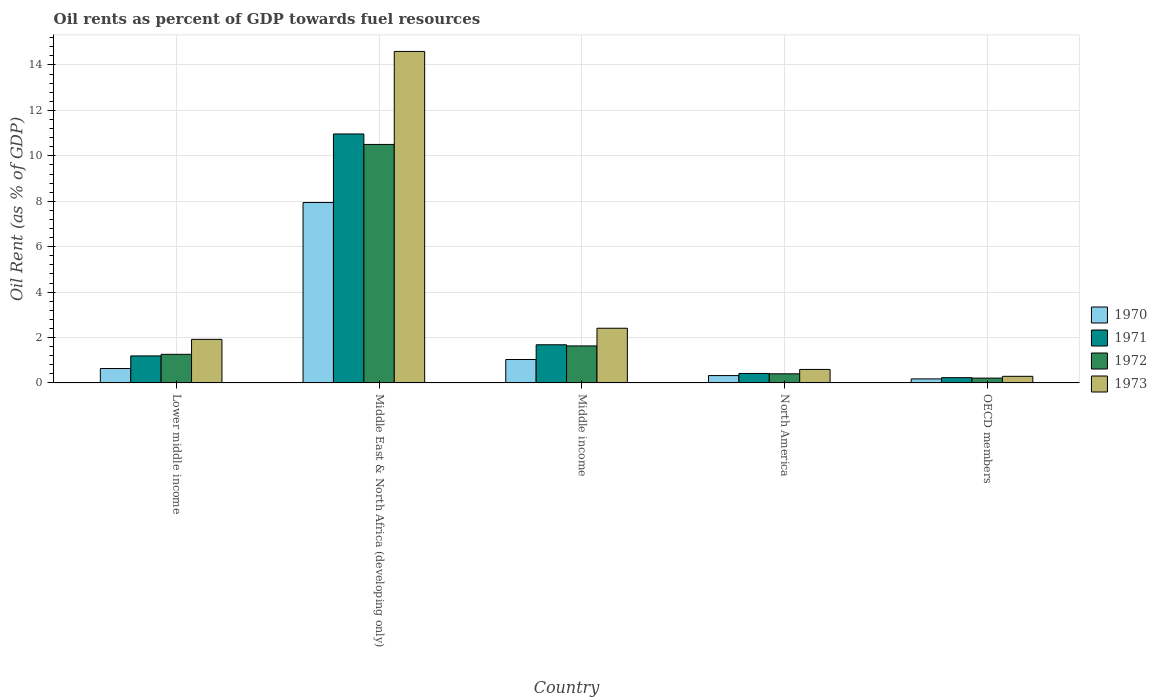How many different coloured bars are there?
Ensure brevity in your answer.  4. How many groups of bars are there?
Make the answer very short. 5. Are the number of bars on each tick of the X-axis equal?
Provide a succinct answer. Yes. How many bars are there on the 3rd tick from the right?
Your answer should be compact. 4. What is the label of the 4th group of bars from the left?
Provide a succinct answer. North America. What is the oil rent in 1972 in Lower middle income?
Provide a succinct answer. 1.26. Across all countries, what is the maximum oil rent in 1970?
Your response must be concise. 7.94. Across all countries, what is the minimum oil rent in 1973?
Give a very brief answer. 0.29. In which country was the oil rent in 1973 maximum?
Keep it short and to the point. Middle East & North Africa (developing only). In which country was the oil rent in 1971 minimum?
Provide a short and direct response. OECD members. What is the total oil rent in 1971 in the graph?
Ensure brevity in your answer.  14.48. What is the difference between the oil rent in 1972 in Middle East & North Africa (developing only) and that in Middle income?
Provide a short and direct response. 8.87. What is the difference between the oil rent in 1973 in Middle income and the oil rent in 1972 in Lower middle income?
Provide a succinct answer. 1.15. What is the average oil rent in 1971 per country?
Ensure brevity in your answer.  2.9. What is the difference between the oil rent of/in 1971 and oil rent of/in 1973 in Lower middle income?
Keep it short and to the point. -0.73. In how many countries, is the oil rent in 1971 greater than 3.6 %?
Provide a succinct answer. 1. What is the ratio of the oil rent in 1971 in Lower middle income to that in OECD members?
Make the answer very short. 5.12. Is the difference between the oil rent in 1971 in Middle income and North America greater than the difference between the oil rent in 1973 in Middle income and North America?
Ensure brevity in your answer.  No. What is the difference between the highest and the second highest oil rent in 1972?
Provide a short and direct response. -8.87. What is the difference between the highest and the lowest oil rent in 1970?
Make the answer very short. 7.77. Is it the case that in every country, the sum of the oil rent in 1973 and oil rent in 1972 is greater than the sum of oil rent in 1970 and oil rent in 1971?
Offer a terse response. No. What does the 2nd bar from the left in North America represents?
Provide a short and direct response. 1971. What does the 3rd bar from the right in North America represents?
Your response must be concise. 1971. Are all the bars in the graph horizontal?
Keep it short and to the point. No. What is the difference between two consecutive major ticks on the Y-axis?
Provide a succinct answer. 2. Does the graph contain any zero values?
Offer a very short reply. No. Does the graph contain grids?
Offer a very short reply. Yes. Where does the legend appear in the graph?
Keep it short and to the point. Center right. What is the title of the graph?
Provide a succinct answer. Oil rents as percent of GDP towards fuel resources. What is the label or title of the Y-axis?
Provide a short and direct response. Oil Rent (as % of GDP). What is the Oil Rent (as % of GDP) of 1970 in Lower middle income?
Keep it short and to the point. 0.63. What is the Oil Rent (as % of GDP) in 1971 in Lower middle income?
Give a very brief answer. 1.19. What is the Oil Rent (as % of GDP) in 1972 in Lower middle income?
Your response must be concise. 1.26. What is the Oil Rent (as % of GDP) in 1973 in Lower middle income?
Provide a short and direct response. 1.92. What is the Oil Rent (as % of GDP) in 1970 in Middle East & North Africa (developing only)?
Offer a very short reply. 7.94. What is the Oil Rent (as % of GDP) in 1971 in Middle East & North Africa (developing only)?
Your answer should be very brief. 10.96. What is the Oil Rent (as % of GDP) in 1972 in Middle East & North Africa (developing only)?
Your response must be concise. 10.5. What is the Oil Rent (as % of GDP) of 1973 in Middle East & North Africa (developing only)?
Provide a short and direct response. 14.6. What is the Oil Rent (as % of GDP) in 1970 in Middle income?
Make the answer very short. 1.03. What is the Oil Rent (as % of GDP) of 1971 in Middle income?
Your response must be concise. 1.68. What is the Oil Rent (as % of GDP) in 1972 in Middle income?
Offer a terse response. 1.63. What is the Oil Rent (as % of GDP) of 1973 in Middle income?
Your answer should be very brief. 2.41. What is the Oil Rent (as % of GDP) of 1970 in North America?
Make the answer very short. 0.32. What is the Oil Rent (as % of GDP) of 1971 in North America?
Offer a terse response. 0.42. What is the Oil Rent (as % of GDP) of 1972 in North America?
Your answer should be very brief. 0.4. What is the Oil Rent (as % of GDP) in 1973 in North America?
Provide a short and direct response. 0.6. What is the Oil Rent (as % of GDP) in 1970 in OECD members?
Ensure brevity in your answer.  0.18. What is the Oil Rent (as % of GDP) of 1971 in OECD members?
Keep it short and to the point. 0.23. What is the Oil Rent (as % of GDP) of 1972 in OECD members?
Offer a terse response. 0.21. What is the Oil Rent (as % of GDP) of 1973 in OECD members?
Ensure brevity in your answer.  0.29. Across all countries, what is the maximum Oil Rent (as % of GDP) of 1970?
Your answer should be compact. 7.94. Across all countries, what is the maximum Oil Rent (as % of GDP) in 1971?
Your answer should be very brief. 10.96. Across all countries, what is the maximum Oil Rent (as % of GDP) in 1972?
Keep it short and to the point. 10.5. Across all countries, what is the maximum Oil Rent (as % of GDP) in 1973?
Provide a short and direct response. 14.6. Across all countries, what is the minimum Oil Rent (as % of GDP) in 1970?
Give a very brief answer. 0.18. Across all countries, what is the minimum Oil Rent (as % of GDP) of 1971?
Make the answer very short. 0.23. Across all countries, what is the minimum Oil Rent (as % of GDP) of 1972?
Your answer should be very brief. 0.21. Across all countries, what is the minimum Oil Rent (as % of GDP) in 1973?
Keep it short and to the point. 0.29. What is the total Oil Rent (as % of GDP) in 1970 in the graph?
Your answer should be very brief. 10.11. What is the total Oil Rent (as % of GDP) of 1971 in the graph?
Give a very brief answer. 14.48. What is the total Oil Rent (as % of GDP) in 1972 in the graph?
Your response must be concise. 14.01. What is the total Oil Rent (as % of GDP) in 1973 in the graph?
Make the answer very short. 19.81. What is the difference between the Oil Rent (as % of GDP) in 1970 in Lower middle income and that in Middle East & North Africa (developing only)?
Offer a terse response. -7.31. What is the difference between the Oil Rent (as % of GDP) in 1971 in Lower middle income and that in Middle East & North Africa (developing only)?
Provide a short and direct response. -9.77. What is the difference between the Oil Rent (as % of GDP) in 1972 in Lower middle income and that in Middle East & North Africa (developing only)?
Your answer should be very brief. -9.24. What is the difference between the Oil Rent (as % of GDP) in 1973 in Lower middle income and that in Middle East & North Africa (developing only)?
Provide a succinct answer. -12.68. What is the difference between the Oil Rent (as % of GDP) in 1970 in Lower middle income and that in Middle income?
Offer a very short reply. -0.4. What is the difference between the Oil Rent (as % of GDP) in 1971 in Lower middle income and that in Middle income?
Your response must be concise. -0.49. What is the difference between the Oil Rent (as % of GDP) in 1972 in Lower middle income and that in Middle income?
Keep it short and to the point. -0.37. What is the difference between the Oil Rent (as % of GDP) of 1973 in Lower middle income and that in Middle income?
Your answer should be compact. -0.49. What is the difference between the Oil Rent (as % of GDP) of 1970 in Lower middle income and that in North America?
Keep it short and to the point. 0.31. What is the difference between the Oil Rent (as % of GDP) of 1971 in Lower middle income and that in North America?
Give a very brief answer. 0.77. What is the difference between the Oil Rent (as % of GDP) in 1972 in Lower middle income and that in North America?
Your answer should be compact. 0.86. What is the difference between the Oil Rent (as % of GDP) of 1973 in Lower middle income and that in North America?
Provide a short and direct response. 1.32. What is the difference between the Oil Rent (as % of GDP) of 1970 in Lower middle income and that in OECD members?
Provide a succinct answer. 0.46. What is the difference between the Oil Rent (as % of GDP) of 1971 in Lower middle income and that in OECD members?
Offer a very short reply. 0.96. What is the difference between the Oil Rent (as % of GDP) in 1972 in Lower middle income and that in OECD members?
Offer a terse response. 1.05. What is the difference between the Oil Rent (as % of GDP) of 1973 in Lower middle income and that in OECD members?
Offer a terse response. 1.63. What is the difference between the Oil Rent (as % of GDP) of 1970 in Middle East & North Africa (developing only) and that in Middle income?
Your answer should be compact. 6.91. What is the difference between the Oil Rent (as % of GDP) in 1971 in Middle East & North Africa (developing only) and that in Middle income?
Your response must be concise. 9.28. What is the difference between the Oil Rent (as % of GDP) in 1972 in Middle East & North Africa (developing only) and that in Middle income?
Offer a very short reply. 8.87. What is the difference between the Oil Rent (as % of GDP) of 1973 in Middle East & North Africa (developing only) and that in Middle income?
Provide a short and direct response. 12.19. What is the difference between the Oil Rent (as % of GDP) of 1970 in Middle East & North Africa (developing only) and that in North America?
Provide a short and direct response. 7.62. What is the difference between the Oil Rent (as % of GDP) in 1971 in Middle East & North Africa (developing only) and that in North America?
Provide a succinct answer. 10.55. What is the difference between the Oil Rent (as % of GDP) of 1972 in Middle East & North Africa (developing only) and that in North America?
Provide a succinct answer. 10.1. What is the difference between the Oil Rent (as % of GDP) of 1973 in Middle East & North Africa (developing only) and that in North America?
Keep it short and to the point. 14. What is the difference between the Oil Rent (as % of GDP) of 1970 in Middle East & North Africa (developing only) and that in OECD members?
Your answer should be very brief. 7.77. What is the difference between the Oil Rent (as % of GDP) in 1971 in Middle East & North Africa (developing only) and that in OECD members?
Ensure brevity in your answer.  10.73. What is the difference between the Oil Rent (as % of GDP) in 1972 in Middle East & North Africa (developing only) and that in OECD members?
Keep it short and to the point. 10.29. What is the difference between the Oil Rent (as % of GDP) in 1973 in Middle East & North Africa (developing only) and that in OECD members?
Ensure brevity in your answer.  14.3. What is the difference between the Oil Rent (as % of GDP) of 1970 in Middle income and that in North America?
Your response must be concise. 0.71. What is the difference between the Oil Rent (as % of GDP) in 1971 in Middle income and that in North America?
Give a very brief answer. 1.26. What is the difference between the Oil Rent (as % of GDP) of 1972 in Middle income and that in North America?
Give a very brief answer. 1.23. What is the difference between the Oil Rent (as % of GDP) in 1973 in Middle income and that in North America?
Offer a terse response. 1.81. What is the difference between the Oil Rent (as % of GDP) of 1970 in Middle income and that in OECD members?
Make the answer very short. 0.85. What is the difference between the Oil Rent (as % of GDP) of 1971 in Middle income and that in OECD members?
Provide a succinct answer. 1.45. What is the difference between the Oil Rent (as % of GDP) in 1972 in Middle income and that in OECD members?
Your answer should be compact. 1.42. What is the difference between the Oil Rent (as % of GDP) of 1973 in Middle income and that in OECD members?
Ensure brevity in your answer.  2.12. What is the difference between the Oil Rent (as % of GDP) of 1970 in North America and that in OECD members?
Provide a succinct answer. 0.15. What is the difference between the Oil Rent (as % of GDP) of 1971 in North America and that in OECD members?
Your response must be concise. 0.18. What is the difference between the Oil Rent (as % of GDP) in 1972 in North America and that in OECD members?
Your response must be concise. 0.19. What is the difference between the Oil Rent (as % of GDP) in 1973 in North America and that in OECD members?
Provide a succinct answer. 0.3. What is the difference between the Oil Rent (as % of GDP) in 1970 in Lower middle income and the Oil Rent (as % of GDP) in 1971 in Middle East & North Africa (developing only)?
Provide a succinct answer. -10.33. What is the difference between the Oil Rent (as % of GDP) of 1970 in Lower middle income and the Oil Rent (as % of GDP) of 1972 in Middle East & North Africa (developing only)?
Offer a very short reply. -9.87. What is the difference between the Oil Rent (as % of GDP) in 1970 in Lower middle income and the Oil Rent (as % of GDP) in 1973 in Middle East & North Africa (developing only)?
Make the answer very short. -13.96. What is the difference between the Oil Rent (as % of GDP) of 1971 in Lower middle income and the Oil Rent (as % of GDP) of 1972 in Middle East & North Africa (developing only)?
Your answer should be compact. -9.31. What is the difference between the Oil Rent (as % of GDP) of 1971 in Lower middle income and the Oil Rent (as % of GDP) of 1973 in Middle East & North Africa (developing only)?
Provide a succinct answer. -13.41. What is the difference between the Oil Rent (as % of GDP) in 1972 in Lower middle income and the Oil Rent (as % of GDP) in 1973 in Middle East & North Africa (developing only)?
Offer a terse response. -13.34. What is the difference between the Oil Rent (as % of GDP) in 1970 in Lower middle income and the Oil Rent (as % of GDP) in 1971 in Middle income?
Ensure brevity in your answer.  -1.05. What is the difference between the Oil Rent (as % of GDP) of 1970 in Lower middle income and the Oil Rent (as % of GDP) of 1972 in Middle income?
Your response must be concise. -1. What is the difference between the Oil Rent (as % of GDP) in 1970 in Lower middle income and the Oil Rent (as % of GDP) in 1973 in Middle income?
Offer a very short reply. -1.77. What is the difference between the Oil Rent (as % of GDP) of 1971 in Lower middle income and the Oil Rent (as % of GDP) of 1972 in Middle income?
Ensure brevity in your answer.  -0.44. What is the difference between the Oil Rent (as % of GDP) in 1971 in Lower middle income and the Oil Rent (as % of GDP) in 1973 in Middle income?
Provide a succinct answer. -1.22. What is the difference between the Oil Rent (as % of GDP) in 1972 in Lower middle income and the Oil Rent (as % of GDP) in 1973 in Middle income?
Ensure brevity in your answer.  -1.15. What is the difference between the Oil Rent (as % of GDP) in 1970 in Lower middle income and the Oil Rent (as % of GDP) in 1971 in North America?
Provide a succinct answer. 0.22. What is the difference between the Oil Rent (as % of GDP) in 1970 in Lower middle income and the Oil Rent (as % of GDP) in 1972 in North America?
Offer a very short reply. 0.23. What is the difference between the Oil Rent (as % of GDP) in 1970 in Lower middle income and the Oil Rent (as % of GDP) in 1973 in North America?
Offer a terse response. 0.04. What is the difference between the Oil Rent (as % of GDP) of 1971 in Lower middle income and the Oil Rent (as % of GDP) of 1972 in North America?
Your answer should be very brief. 0.79. What is the difference between the Oil Rent (as % of GDP) of 1971 in Lower middle income and the Oil Rent (as % of GDP) of 1973 in North America?
Make the answer very short. 0.6. What is the difference between the Oil Rent (as % of GDP) in 1972 in Lower middle income and the Oil Rent (as % of GDP) in 1973 in North America?
Keep it short and to the point. 0.66. What is the difference between the Oil Rent (as % of GDP) of 1970 in Lower middle income and the Oil Rent (as % of GDP) of 1971 in OECD members?
Your answer should be compact. 0.4. What is the difference between the Oil Rent (as % of GDP) of 1970 in Lower middle income and the Oil Rent (as % of GDP) of 1972 in OECD members?
Your response must be concise. 0.42. What is the difference between the Oil Rent (as % of GDP) in 1970 in Lower middle income and the Oil Rent (as % of GDP) in 1973 in OECD members?
Offer a very short reply. 0.34. What is the difference between the Oil Rent (as % of GDP) of 1971 in Lower middle income and the Oil Rent (as % of GDP) of 1972 in OECD members?
Make the answer very short. 0.98. What is the difference between the Oil Rent (as % of GDP) of 1971 in Lower middle income and the Oil Rent (as % of GDP) of 1973 in OECD members?
Your answer should be compact. 0.9. What is the difference between the Oil Rent (as % of GDP) of 1972 in Lower middle income and the Oil Rent (as % of GDP) of 1973 in OECD members?
Your response must be concise. 0.97. What is the difference between the Oil Rent (as % of GDP) of 1970 in Middle East & North Africa (developing only) and the Oil Rent (as % of GDP) of 1971 in Middle income?
Your answer should be compact. 6.26. What is the difference between the Oil Rent (as % of GDP) in 1970 in Middle East & North Africa (developing only) and the Oil Rent (as % of GDP) in 1972 in Middle income?
Make the answer very short. 6.31. What is the difference between the Oil Rent (as % of GDP) of 1970 in Middle East & North Africa (developing only) and the Oil Rent (as % of GDP) of 1973 in Middle income?
Make the answer very short. 5.53. What is the difference between the Oil Rent (as % of GDP) of 1971 in Middle East & North Africa (developing only) and the Oil Rent (as % of GDP) of 1972 in Middle income?
Your response must be concise. 9.33. What is the difference between the Oil Rent (as % of GDP) of 1971 in Middle East & North Africa (developing only) and the Oil Rent (as % of GDP) of 1973 in Middle income?
Ensure brevity in your answer.  8.55. What is the difference between the Oil Rent (as % of GDP) in 1972 in Middle East & North Africa (developing only) and the Oil Rent (as % of GDP) in 1973 in Middle income?
Give a very brief answer. 8.09. What is the difference between the Oil Rent (as % of GDP) of 1970 in Middle East & North Africa (developing only) and the Oil Rent (as % of GDP) of 1971 in North America?
Keep it short and to the point. 7.53. What is the difference between the Oil Rent (as % of GDP) of 1970 in Middle East & North Africa (developing only) and the Oil Rent (as % of GDP) of 1972 in North America?
Ensure brevity in your answer.  7.54. What is the difference between the Oil Rent (as % of GDP) in 1970 in Middle East & North Africa (developing only) and the Oil Rent (as % of GDP) in 1973 in North America?
Keep it short and to the point. 7.35. What is the difference between the Oil Rent (as % of GDP) of 1971 in Middle East & North Africa (developing only) and the Oil Rent (as % of GDP) of 1972 in North America?
Provide a succinct answer. 10.56. What is the difference between the Oil Rent (as % of GDP) of 1971 in Middle East & North Africa (developing only) and the Oil Rent (as % of GDP) of 1973 in North America?
Give a very brief answer. 10.37. What is the difference between the Oil Rent (as % of GDP) in 1972 in Middle East & North Africa (developing only) and the Oil Rent (as % of GDP) in 1973 in North America?
Your answer should be compact. 9.91. What is the difference between the Oil Rent (as % of GDP) of 1970 in Middle East & North Africa (developing only) and the Oil Rent (as % of GDP) of 1971 in OECD members?
Keep it short and to the point. 7.71. What is the difference between the Oil Rent (as % of GDP) of 1970 in Middle East & North Africa (developing only) and the Oil Rent (as % of GDP) of 1972 in OECD members?
Ensure brevity in your answer.  7.73. What is the difference between the Oil Rent (as % of GDP) in 1970 in Middle East & North Africa (developing only) and the Oil Rent (as % of GDP) in 1973 in OECD members?
Offer a very short reply. 7.65. What is the difference between the Oil Rent (as % of GDP) in 1971 in Middle East & North Africa (developing only) and the Oil Rent (as % of GDP) in 1972 in OECD members?
Keep it short and to the point. 10.75. What is the difference between the Oil Rent (as % of GDP) of 1971 in Middle East & North Africa (developing only) and the Oil Rent (as % of GDP) of 1973 in OECD members?
Your answer should be compact. 10.67. What is the difference between the Oil Rent (as % of GDP) in 1972 in Middle East & North Africa (developing only) and the Oil Rent (as % of GDP) in 1973 in OECD members?
Ensure brevity in your answer.  10.21. What is the difference between the Oil Rent (as % of GDP) in 1970 in Middle income and the Oil Rent (as % of GDP) in 1971 in North America?
Give a very brief answer. 0.61. What is the difference between the Oil Rent (as % of GDP) of 1970 in Middle income and the Oil Rent (as % of GDP) of 1972 in North America?
Your answer should be very brief. 0.63. What is the difference between the Oil Rent (as % of GDP) in 1970 in Middle income and the Oil Rent (as % of GDP) in 1973 in North America?
Provide a short and direct response. 0.44. What is the difference between the Oil Rent (as % of GDP) of 1971 in Middle income and the Oil Rent (as % of GDP) of 1972 in North America?
Offer a terse response. 1.28. What is the difference between the Oil Rent (as % of GDP) in 1971 in Middle income and the Oil Rent (as % of GDP) in 1973 in North America?
Provide a succinct answer. 1.09. What is the difference between the Oil Rent (as % of GDP) in 1972 in Middle income and the Oil Rent (as % of GDP) in 1973 in North America?
Offer a terse response. 1.04. What is the difference between the Oil Rent (as % of GDP) in 1970 in Middle income and the Oil Rent (as % of GDP) in 1971 in OECD members?
Offer a terse response. 0.8. What is the difference between the Oil Rent (as % of GDP) of 1970 in Middle income and the Oil Rent (as % of GDP) of 1972 in OECD members?
Keep it short and to the point. 0.82. What is the difference between the Oil Rent (as % of GDP) in 1970 in Middle income and the Oil Rent (as % of GDP) in 1973 in OECD members?
Your answer should be compact. 0.74. What is the difference between the Oil Rent (as % of GDP) in 1971 in Middle income and the Oil Rent (as % of GDP) in 1972 in OECD members?
Your response must be concise. 1.47. What is the difference between the Oil Rent (as % of GDP) in 1971 in Middle income and the Oil Rent (as % of GDP) in 1973 in OECD members?
Offer a very short reply. 1.39. What is the difference between the Oil Rent (as % of GDP) of 1972 in Middle income and the Oil Rent (as % of GDP) of 1973 in OECD members?
Provide a short and direct response. 1.34. What is the difference between the Oil Rent (as % of GDP) of 1970 in North America and the Oil Rent (as % of GDP) of 1971 in OECD members?
Your answer should be compact. 0.09. What is the difference between the Oil Rent (as % of GDP) of 1970 in North America and the Oil Rent (as % of GDP) of 1972 in OECD members?
Make the answer very short. 0.11. What is the difference between the Oil Rent (as % of GDP) of 1970 in North America and the Oil Rent (as % of GDP) of 1973 in OECD members?
Your answer should be very brief. 0.03. What is the difference between the Oil Rent (as % of GDP) of 1971 in North America and the Oil Rent (as % of GDP) of 1972 in OECD members?
Your answer should be very brief. 0.21. What is the difference between the Oil Rent (as % of GDP) of 1971 in North America and the Oil Rent (as % of GDP) of 1973 in OECD members?
Ensure brevity in your answer.  0.13. What is the difference between the Oil Rent (as % of GDP) of 1972 in North America and the Oil Rent (as % of GDP) of 1973 in OECD members?
Make the answer very short. 0.11. What is the average Oil Rent (as % of GDP) of 1970 per country?
Make the answer very short. 2.02. What is the average Oil Rent (as % of GDP) in 1971 per country?
Keep it short and to the point. 2.9. What is the average Oil Rent (as % of GDP) of 1972 per country?
Make the answer very short. 2.8. What is the average Oil Rent (as % of GDP) of 1973 per country?
Provide a short and direct response. 3.96. What is the difference between the Oil Rent (as % of GDP) in 1970 and Oil Rent (as % of GDP) in 1971 in Lower middle income?
Provide a succinct answer. -0.56. What is the difference between the Oil Rent (as % of GDP) in 1970 and Oil Rent (as % of GDP) in 1972 in Lower middle income?
Give a very brief answer. -0.62. What is the difference between the Oil Rent (as % of GDP) of 1970 and Oil Rent (as % of GDP) of 1973 in Lower middle income?
Provide a succinct answer. -1.28. What is the difference between the Oil Rent (as % of GDP) of 1971 and Oil Rent (as % of GDP) of 1972 in Lower middle income?
Make the answer very short. -0.07. What is the difference between the Oil Rent (as % of GDP) of 1971 and Oil Rent (as % of GDP) of 1973 in Lower middle income?
Offer a terse response. -0.73. What is the difference between the Oil Rent (as % of GDP) in 1972 and Oil Rent (as % of GDP) in 1973 in Lower middle income?
Your answer should be compact. -0.66. What is the difference between the Oil Rent (as % of GDP) in 1970 and Oil Rent (as % of GDP) in 1971 in Middle East & North Africa (developing only)?
Keep it short and to the point. -3.02. What is the difference between the Oil Rent (as % of GDP) of 1970 and Oil Rent (as % of GDP) of 1972 in Middle East & North Africa (developing only)?
Keep it short and to the point. -2.56. What is the difference between the Oil Rent (as % of GDP) of 1970 and Oil Rent (as % of GDP) of 1973 in Middle East & North Africa (developing only)?
Ensure brevity in your answer.  -6.65. What is the difference between the Oil Rent (as % of GDP) of 1971 and Oil Rent (as % of GDP) of 1972 in Middle East & North Africa (developing only)?
Ensure brevity in your answer.  0.46. What is the difference between the Oil Rent (as % of GDP) of 1971 and Oil Rent (as % of GDP) of 1973 in Middle East & North Africa (developing only)?
Give a very brief answer. -3.63. What is the difference between the Oil Rent (as % of GDP) of 1972 and Oil Rent (as % of GDP) of 1973 in Middle East & North Africa (developing only)?
Your answer should be very brief. -4.09. What is the difference between the Oil Rent (as % of GDP) in 1970 and Oil Rent (as % of GDP) in 1971 in Middle income?
Make the answer very short. -0.65. What is the difference between the Oil Rent (as % of GDP) of 1970 and Oil Rent (as % of GDP) of 1972 in Middle income?
Your response must be concise. -0.6. What is the difference between the Oil Rent (as % of GDP) of 1970 and Oil Rent (as % of GDP) of 1973 in Middle income?
Offer a terse response. -1.38. What is the difference between the Oil Rent (as % of GDP) in 1971 and Oil Rent (as % of GDP) in 1972 in Middle income?
Your answer should be very brief. 0.05. What is the difference between the Oil Rent (as % of GDP) of 1971 and Oil Rent (as % of GDP) of 1973 in Middle income?
Your answer should be compact. -0.73. What is the difference between the Oil Rent (as % of GDP) of 1972 and Oil Rent (as % of GDP) of 1973 in Middle income?
Your response must be concise. -0.78. What is the difference between the Oil Rent (as % of GDP) in 1970 and Oil Rent (as % of GDP) in 1971 in North America?
Offer a very short reply. -0.09. What is the difference between the Oil Rent (as % of GDP) in 1970 and Oil Rent (as % of GDP) in 1972 in North America?
Your answer should be compact. -0.08. What is the difference between the Oil Rent (as % of GDP) of 1970 and Oil Rent (as % of GDP) of 1973 in North America?
Your answer should be very brief. -0.27. What is the difference between the Oil Rent (as % of GDP) of 1971 and Oil Rent (as % of GDP) of 1972 in North America?
Offer a terse response. 0.02. What is the difference between the Oil Rent (as % of GDP) of 1971 and Oil Rent (as % of GDP) of 1973 in North America?
Keep it short and to the point. -0.18. What is the difference between the Oil Rent (as % of GDP) in 1972 and Oil Rent (as % of GDP) in 1973 in North America?
Your answer should be compact. -0.19. What is the difference between the Oil Rent (as % of GDP) in 1970 and Oil Rent (as % of GDP) in 1971 in OECD members?
Your answer should be very brief. -0.05. What is the difference between the Oil Rent (as % of GDP) of 1970 and Oil Rent (as % of GDP) of 1972 in OECD members?
Provide a short and direct response. -0.03. What is the difference between the Oil Rent (as % of GDP) in 1970 and Oil Rent (as % of GDP) in 1973 in OECD members?
Give a very brief answer. -0.11. What is the difference between the Oil Rent (as % of GDP) of 1971 and Oil Rent (as % of GDP) of 1972 in OECD members?
Ensure brevity in your answer.  0.02. What is the difference between the Oil Rent (as % of GDP) in 1971 and Oil Rent (as % of GDP) in 1973 in OECD members?
Provide a succinct answer. -0.06. What is the difference between the Oil Rent (as % of GDP) in 1972 and Oil Rent (as % of GDP) in 1973 in OECD members?
Your response must be concise. -0.08. What is the ratio of the Oil Rent (as % of GDP) of 1970 in Lower middle income to that in Middle East & North Africa (developing only)?
Your answer should be compact. 0.08. What is the ratio of the Oil Rent (as % of GDP) in 1971 in Lower middle income to that in Middle East & North Africa (developing only)?
Give a very brief answer. 0.11. What is the ratio of the Oil Rent (as % of GDP) in 1972 in Lower middle income to that in Middle East & North Africa (developing only)?
Ensure brevity in your answer.  0.12. What is the ratio of the Oil Rent (as % of GDP) of 1973 in Lower middle income to that in Middle East & North Africa (developing only)?
Your answer should be very brief. 0.13. What is the ratio of the Oil Rent (as % of GDP) of 1970 in Lower middle income to that in Middle income?
Offer a terse response. 0.61. What is the ratio of the Oil Rent (as % of GDP) of 1971 in Lower middle income to that in Middle income?
Provide a short and direct response. 0.71. What is the ratio of the Oil Rent (as % of GDP) of 1972 in Lower middle income to that in Middle income?
Your answer should be compact. 0.77. What is the ratio of the Oil Rent (as % of GDP) in 1973 in Lower middle income to that in Middle income?
Offer a terse response. 0.8. What is the ratio of the Oil Rent (as % of GDP) of 1970 in Lower middle income to that in North America?
Make the answer very short. 1.96. What is the ratio of the Oil Rent (as % of GDP) of 1971 in Lower middle income to that in North America?
Give a very brief answer. 2.85. What is the ratio of the Oil Rent (as % of GDP) of 1972 in Lower middle income to that in North America?
Make the answer very short. 3.13. What is the ratio of the Oil Rent (as % of GDP) in 1973 in Lower middle income to that in North America?
Offer a terse response. 3.22. What is the ratio of the Oil Rent (as % of GDP) of 1970 in Lower middle income to that in OECD members?
Your answer should be very brief. 3.57. What is the ratio of the Oil Rent (as % of GDP) in 1971 in Lower middle income to that in OECD members?
Make the answer very short. 5.12. What is the ratio of the Oil Rent (as % of GDP) of 1972 in Lower middle income to that in OECD members?
Your answer should be very brief. 5.94. What is the ratio of the Oil Rent (as % of GDP) of 1973 in Lower middle income to that in OECD members?
Offer a very short reply. 6.58. What is the ratio of the Oil Rent (as % of GDP) in 1970 in Middle East & North Africa (developing only) to that in Middle income?
Your response must be concise. 7.69. What is the ratio of the Oil Rent (as % of GDP) of 1971 in Middle East & North Africa (developing only) to that in Middle income?
Offer a terse response. 6.52. What is the ratio of the Oil Rent (as % of GDP) in 1972 in Middle East & North Africa (developing only) to that in Middle income?
Give a very brief answer. 6.44. What is the ratio of the Oil Rent (as % of GDP) in 1973 in Middle East & North Africa (developing only) to that in Middle income?
Your answer should be very brief. 6.06. What is the ratio of the Oil Rent (as % of GDP) in 1970 in Middle East & North Africa (developing only) to that in North America?
Your answer should be compact. 24.54. What is the ratio of the Oil Rent (as % of GDP) of 1971 in Middle East & North Africa (developing only) to that in North America?
Your response must be concise. 26.26. What is the ratio of the Oil Rent (as % of GDP) of 1972 in Middle East & North Africa (developing only) to that in North America?
Offer a terse response. 26.11. What is the ratio of the Oil Rent (as % of GDP) in 1973 in Middle East & North Africa (developing only) to that in North America?
Provide a short and direct response. 24.53. What is the ratio of the Oil Rent (as % of GDP) in 1970 in Middle East & North Africa (developing only) to that in OECD members?
Your answer should be very brief. 44.68. What is the ratio of the Oil Rent (as % of GDP) of 1971 in Middle East & North Africa (developing only) to that in OECD members?
Offer a terse response. 47.15. What is the ratio of the Oil Rent (as % of GDP) of 1972 in Middle East & North Africa (developing only) to that in OECD members?
Offer a terse response. 49.49. What is the ratio of the Oil Rent (as % of GDP) of 1973 in Middle East & North Africa (developing only) to that in OECD members?
Give a very brief answer. 50.04. What is the ratio of the Oil Rent (as % of GDP) of 1970 in Middle income to that in North America?
Your answer should be very brief. 3.19. What is the ratio of the Oil Rent (as % of GDP) of 1971 in Middle income to that in North America?
Your answer should be very brief. 4.03. What is the ratio of the Oil Rent (as % of GDP) in 1972 in Middle income to that in North America?
Your answer should be very brief. 4.05. What is the ratio of the Oil Rent (as % of GDP) of 1973 in Middle income to that in North America?
Provide a short and direct response. 4.05. What is the ratio of the Oil Rent (as % of GDP) in 1970 in Middle income to that in OECD members?
Offer a terse response. 5.81. What is the ratio of the Oil Rent (as % of GDP) of 1971 in Middle income to that in OECD members?
Your response must be concise. 7.23. What is the ratio of the Oil Rent (as % of GDP) in 1972 in Middle income to that in OECD members?
Your answer should be compact. 7.68. What is the ratio of the Oil Rent (as % of GDP) in 1973 in Middle income to that in OECD members?
Give a very brief answer. 8.26. What is the ratio of the Oil Rent (as % of GDP) in 1970 in North America to that in OECD members?
Your answer should be compact. 1.82. What is the ratio of the Oil Rent (as % of GDP) in 1971 in North America to that in OECD members?
Keep it short and to the point. 1.8. What is the ratio of the Oil Rent (as % of GDP) in 1972 in North America to that in OECD members?
Your response must be concise. 1.9. What is the ratio of the Oil Rent (as % of GDP) of 1973 in North America to that in OECD members?
Your response must be concise. 2.04. What is the difference between the highest and the second highest Oil Rent (as % of GDP) of 1970?
Your answer should be very brief. 6.91. What is the difference between the highest and the second highest Oil Rent (as % of GDP) in 1971?
Your answer should be compact. 9.28. What is the difference between the highest and the second highest Oil Rent (as % of GDP) in 1972?
Keep it short and to the point. 8.87. What is the difference between the highest and the second highest Oil Rent (as % of GDP) of 1973?
Your answer should be compact. 12.19. What is the difference between the highest and the lowest Oil Rent (as % of GDP) of 1970?
Your response must be concise. 7.77. What is the difference between the highest and the lowest Oil Rent (as % of GDP) in 1971?
Provide a succinct answer. 10.73. What is the difference between the highest and the lowest Oil Rent (as % of GDP) in 1972?
Offer a terse response. 10.29. What is the difference between the highest and the lowest Oil Rent (as % of GDP) in 1973?
Make the answer very short. 14.3. 